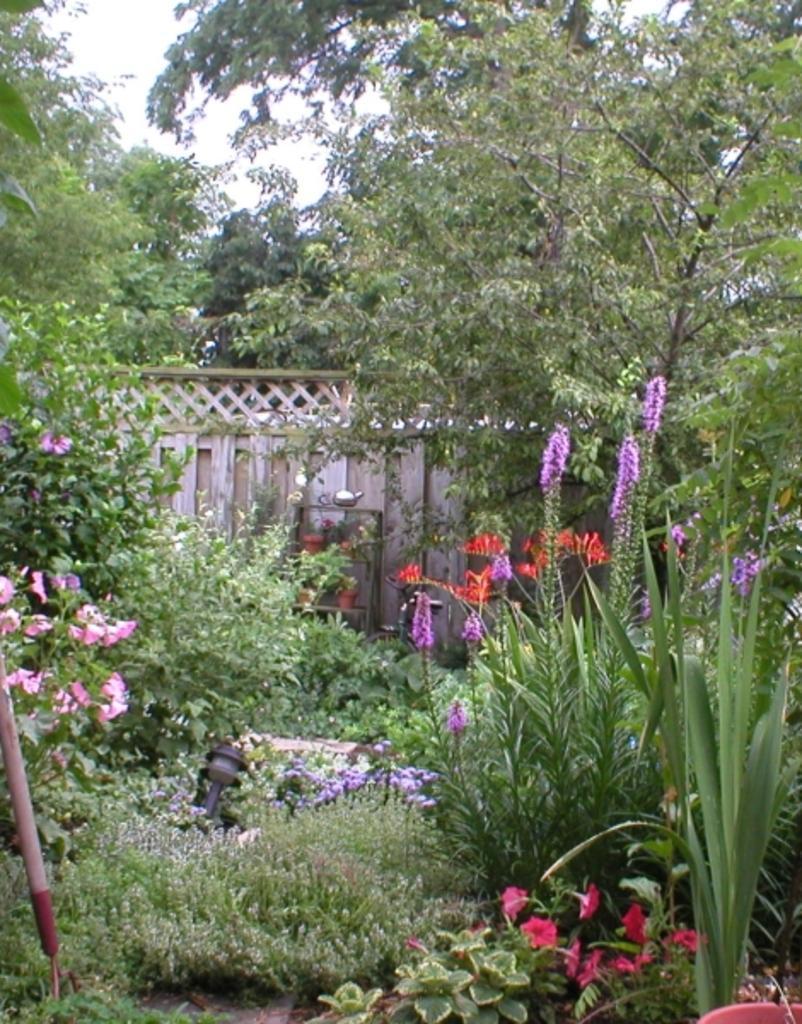Could you give a brief overview of what you see in this image? In this image, we can see some grass and plants. We can see the ground with some objects. We can also see some pots. We can see the wall and the sky. There are a few trees. 